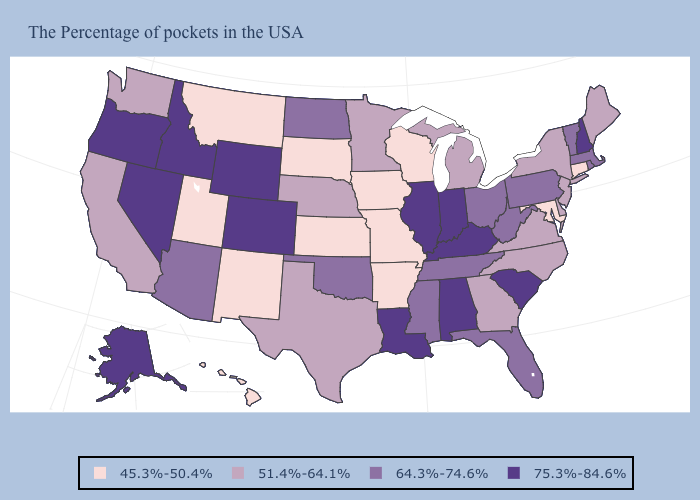Does Vermont have the highest value in the USA?
Be succinct. No. Does Missouri have the lowest value in the USA?
Short answer required. Yes. What is the value of Montana?
Quick response, please. 45.3%-50.4%. Does Connecticut have the lowest value in the USA?
Keep it brief. Yes. Among the states that border Nebraska , which have the highest value?
Give a very brief answer. Wyoming, Colorado. Is the legend a continuous bar?
Short answer required. No. What is the value of North Carolina?
Write a very short answer. 51.4%-64.1%. Among the states that border Missouri , which have the lowest value?
Quick response, please. Arkansas, Iowa, Kansas. Which states have the lowest value in the USA?
Give a very brief answer. Connecticut, Maryland, Wisconsin, Missouri, Arkansas, Iowa, Kansas, South Dakota, New Mexico, Utah, Montana, Hawaii. How many symbols are there in the legend?
Keep it brief. 4. What is the highest value in the West ?
Write a very short answer. 75.3%-84.6%. What is the highest value in states that border Connecticut?
Quick response, please. 64.3%-74.6%. Among the states that border Kansas , does Oklahoma have the highest value?
Quick response, please. No. Among the states that border Nevada , does Utah have the highest value?
Be succinct. No. Does Minnesota have the highest value in the MidWest?
Short answer required. No. 